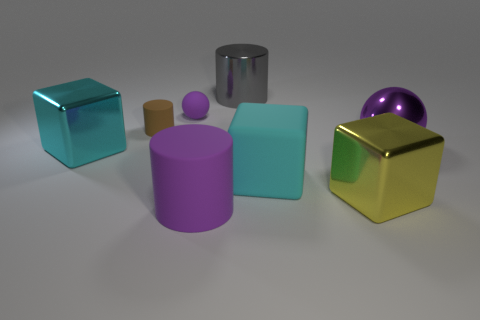How big is the purple rubber cylinder that is right of the ball that is to the left of the big gray metal object?
Your answer should be very brief. Large. What is the shape of the matte object that is in front of the large metal block on the right side of the large object behind the tiny purple matte thing?
Your response must be concise. Cylinder. There is a cylinder that is the same material as the large ball; what color is it?
Give a very brief answer. Gray. What is the color of the metallic object behind the purple ball that is on the right side of the purple ball behind the small brown rubber object?
Keep it short and to the point. Gray. What number of blocks are either cyan shiny things or tiny brown matte things?
Ensure brevity in your answer.  1. There is a big cylinder that is the same color as the small rubber ball; what is its material?
Your answer should be compact. Rubber. Does the big metal cylinder have the same color as the big shiny cube that is right of the big purple rubber thing?
Keep it short and to the point. No. What is the color of the big metallic sphere?
Offer a very short reply. Purple. How many objects are either metallic cubes or purple cylinders?
Make the answer very short. 3. What is the material of the other thing that is the same size as the brown thing?
Your answer should be very brief. Rubber. 